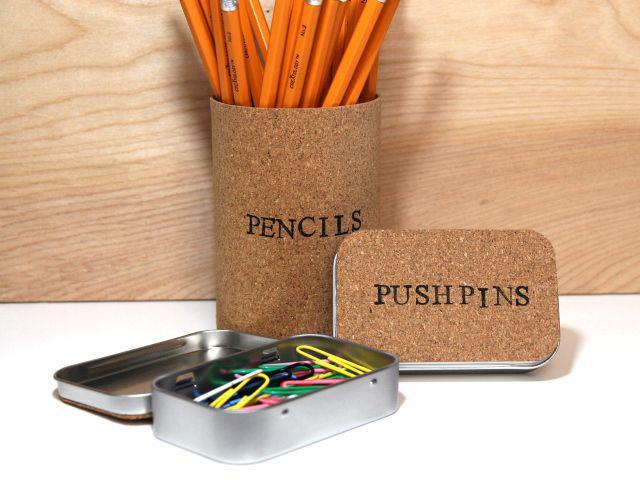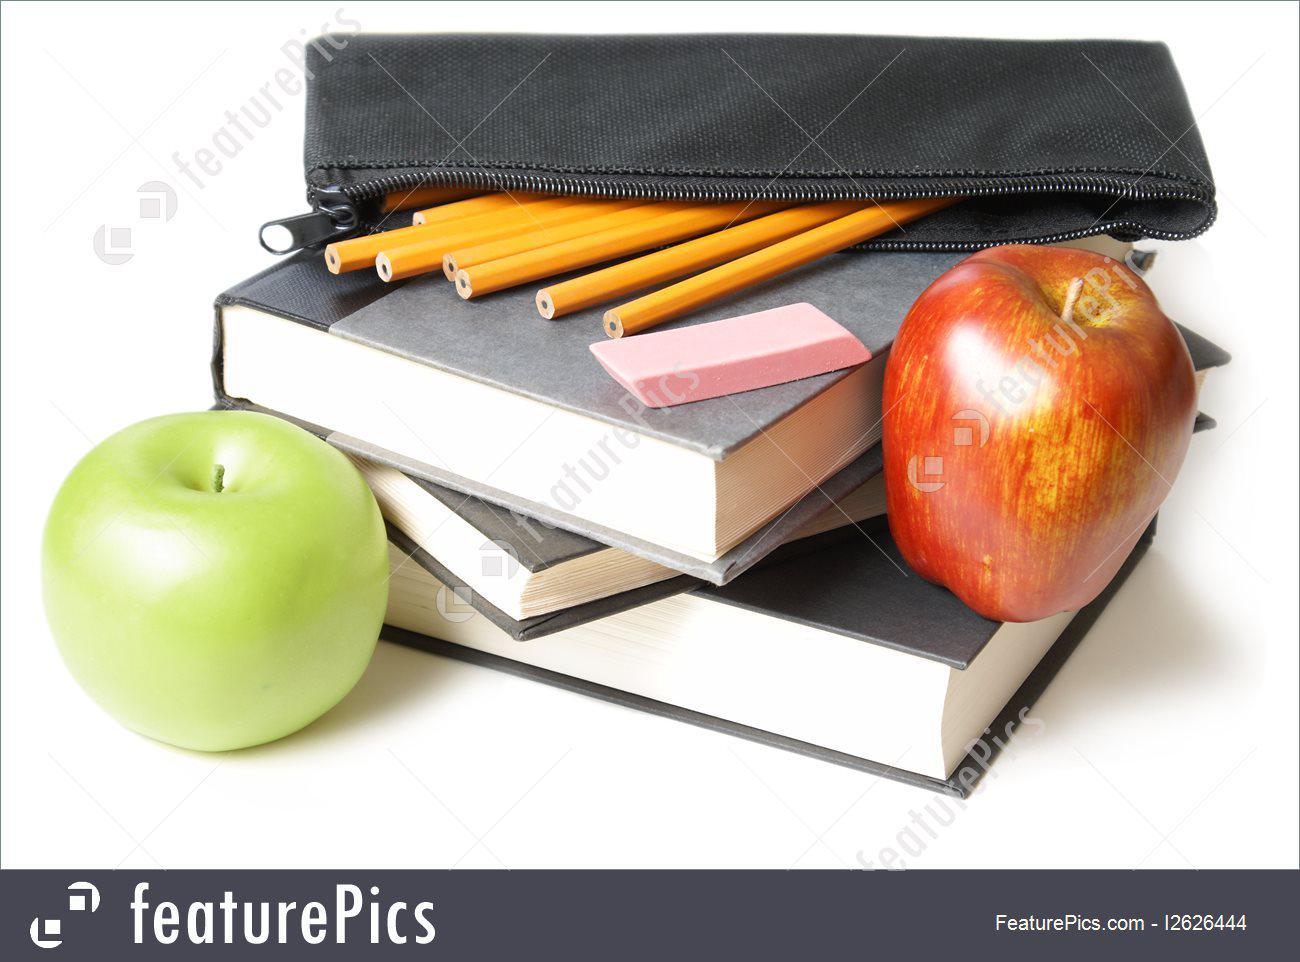The first image is the image on the left, the second image is the image on the right. Assess this claim about the two images: "An image contains at least one green pencil bag with a red zipper.". Correct or not? Answer yes or no. No. The first image is the image on the left, the second image is the image on the right. Analyze the images presented: Is the assertion "One image features a pencil case style with red zipper and green and gray color scheme, and the other image includes various rainbow colors on something black." valid? Answer yes or no. No. 